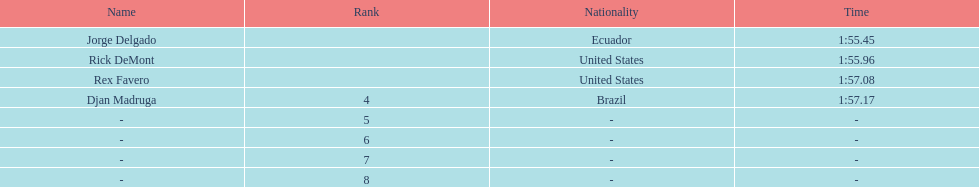What come after rex f. Djan Madruga. 